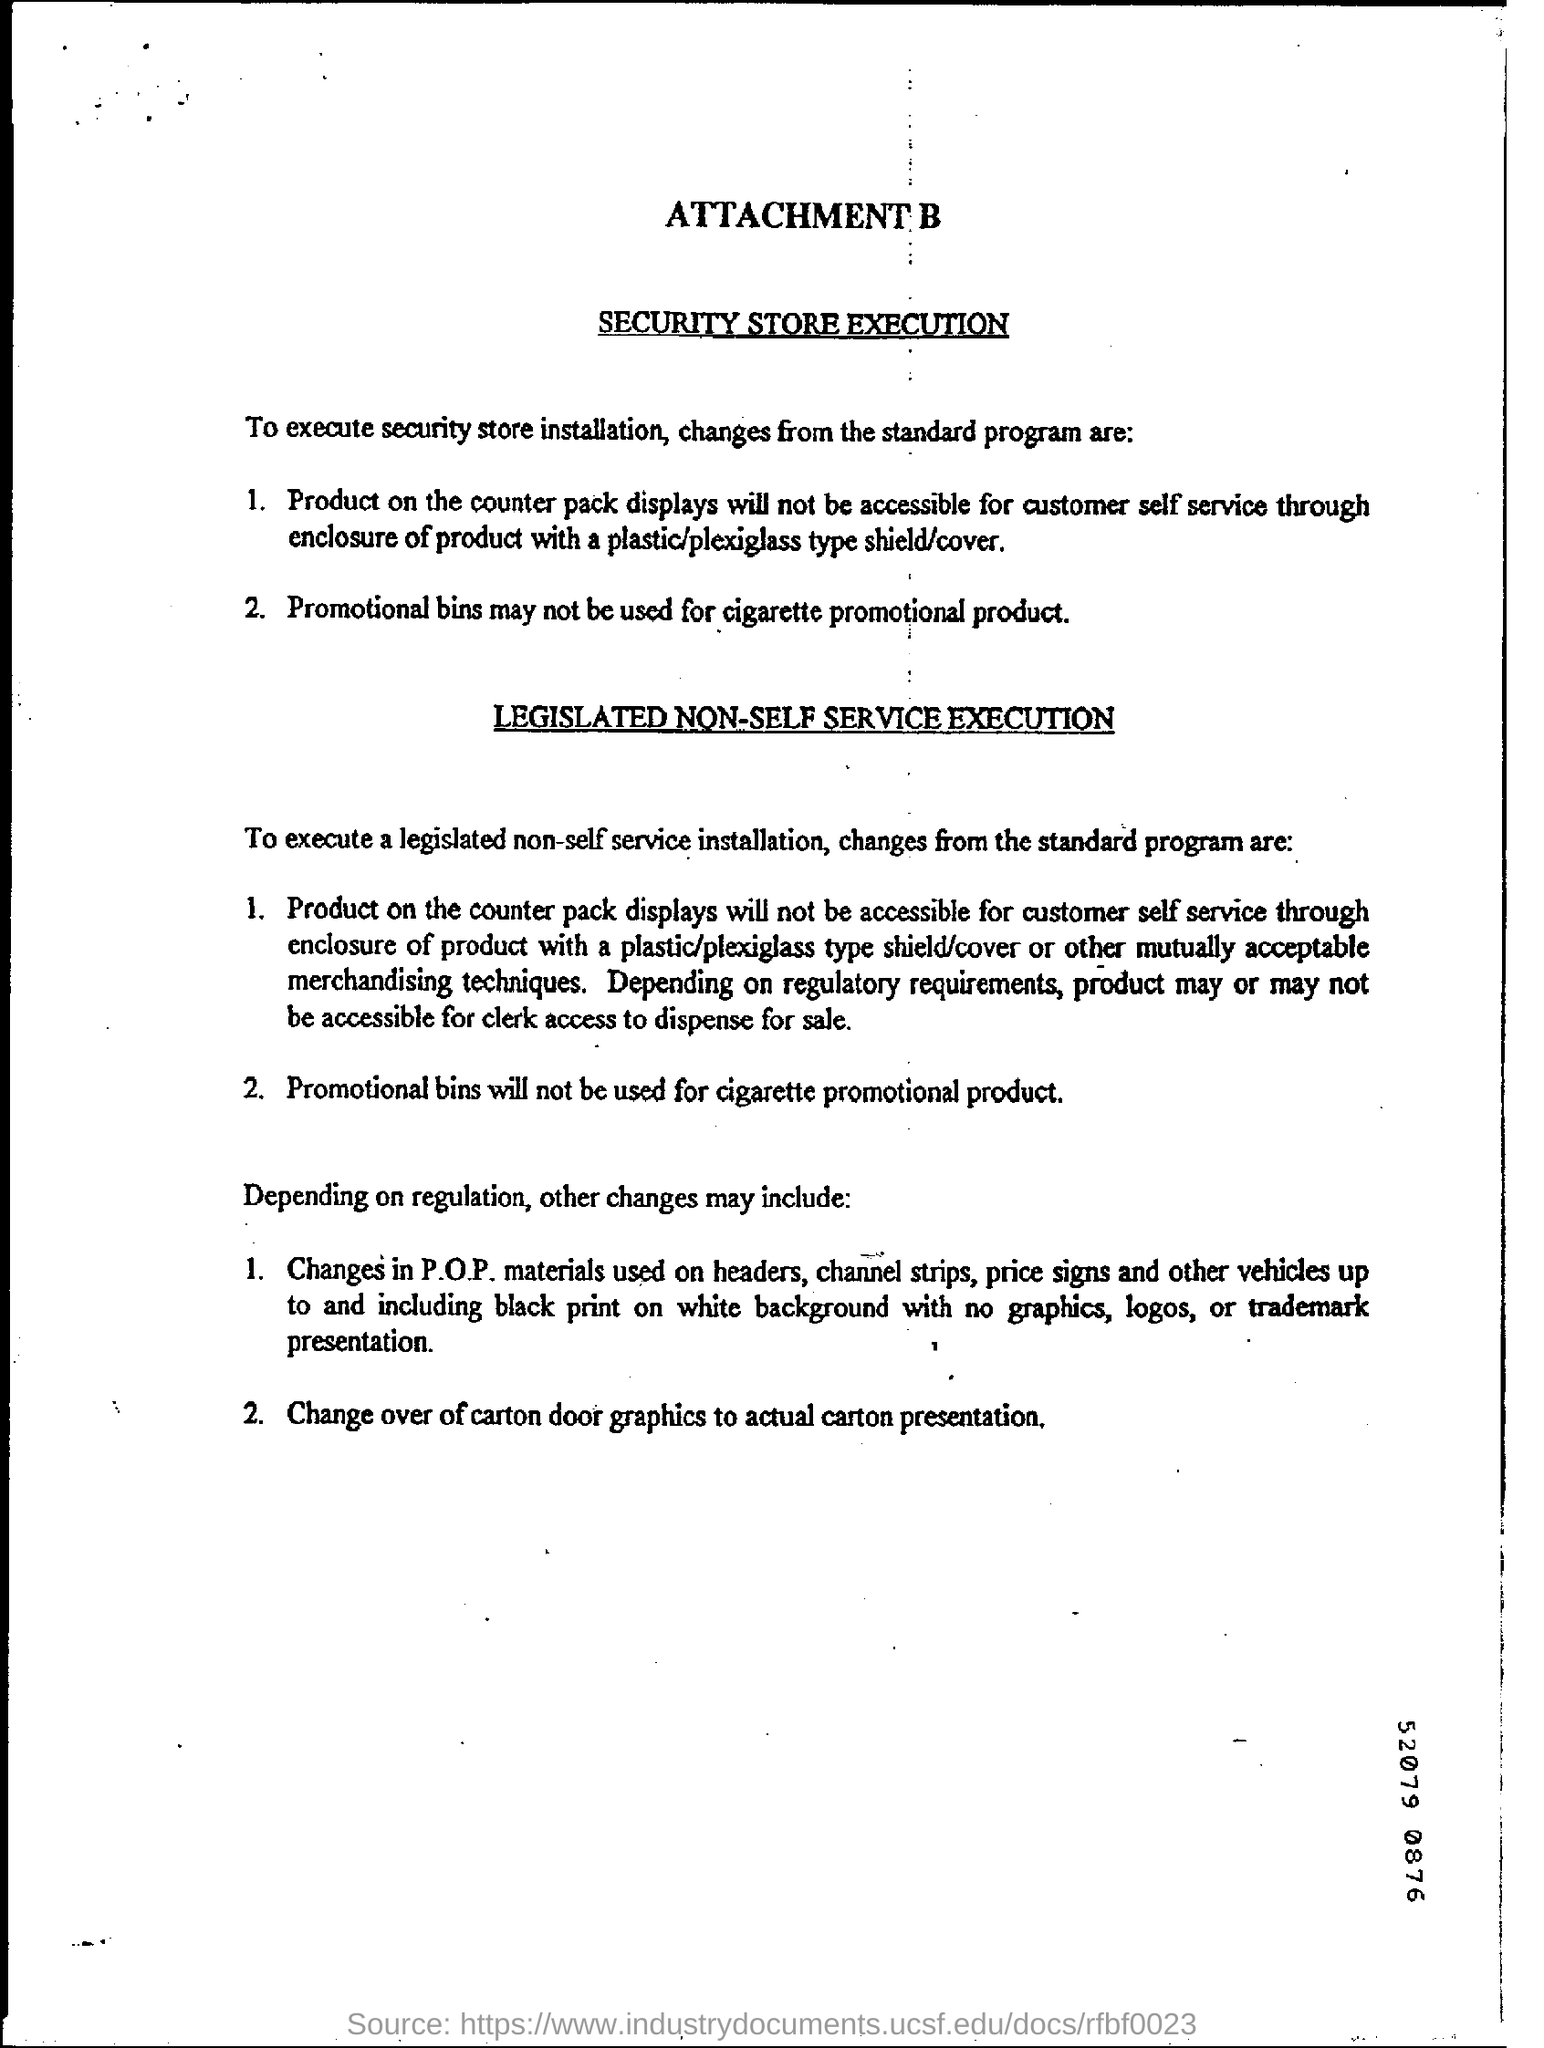Identify some key points in this picture. The digit shown at the bottom right corner of the number 52079 0876 is 5. 